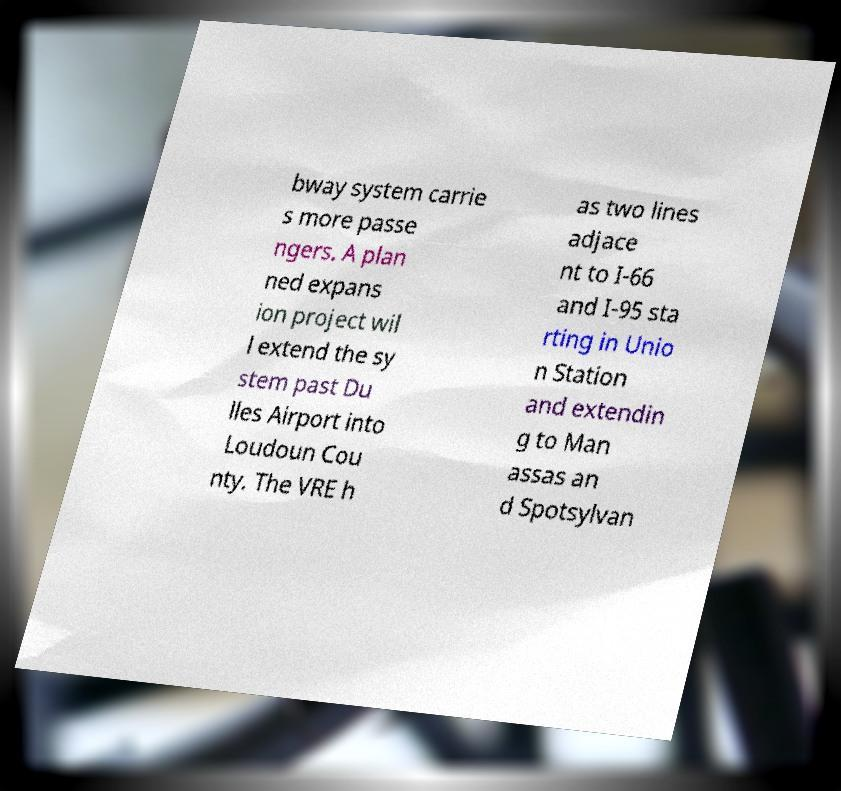Please identify and transcribe the text found in this image. bway system carrie s more passe ngers. A plan ned expans ion project wil l extend the sy stem past Du lles Airport into Loudoun Cou nty. The VRE h as two lines adjace nt to I-66 and I-95 sta rting in Unio n Station and extendin g to Man assas an d Spotsylvan 